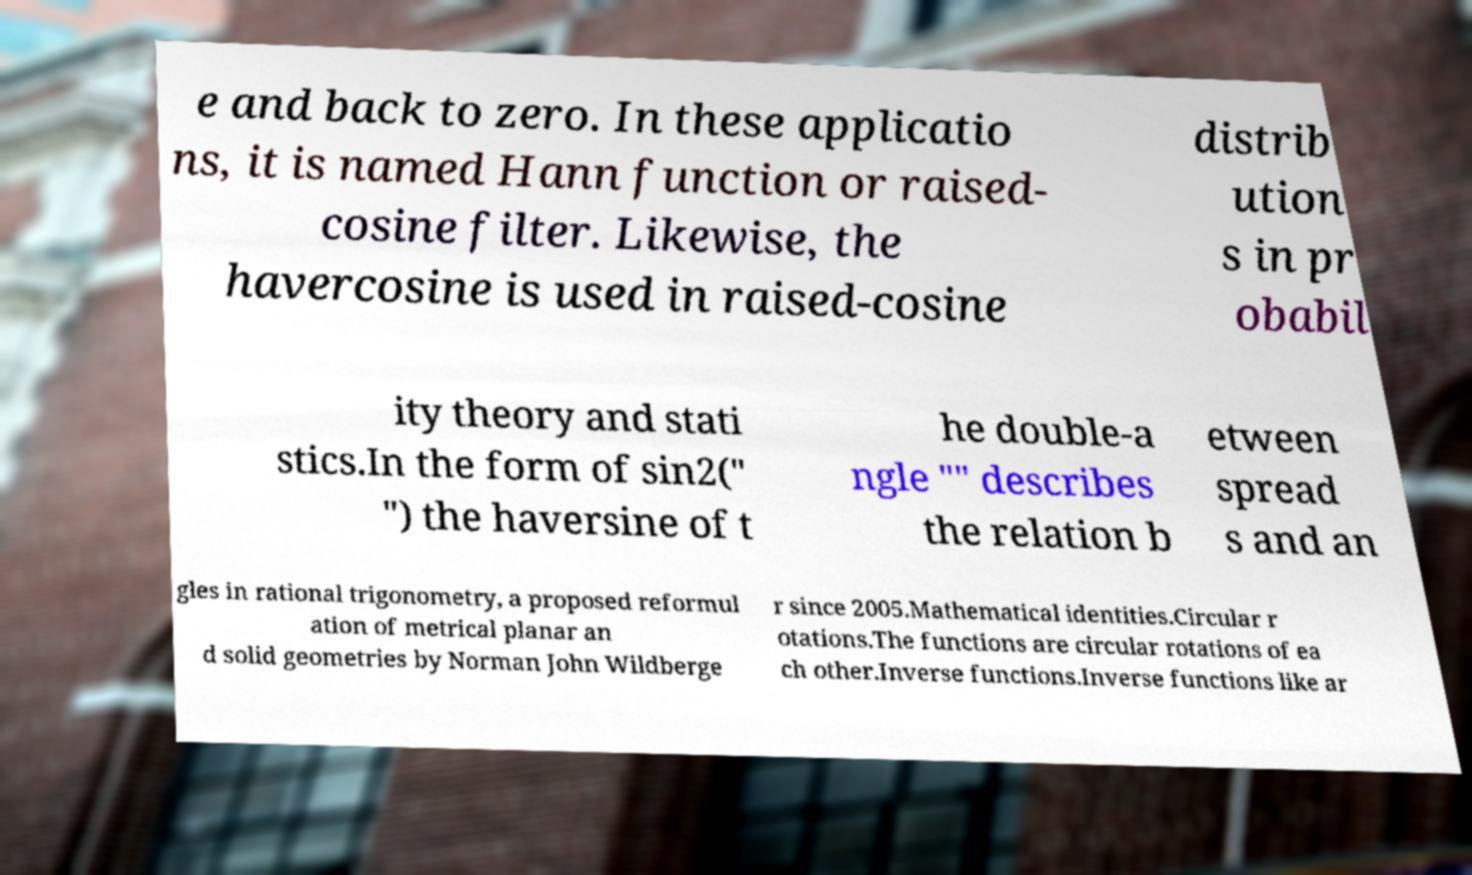Could you assist in decoding the text presented in this image and type it out clearly? e and back to zero. In these applicatio ns, it is named Hann function or raised- cosine filter. Likewise, the havercosine is used in raised-cosine distrib ution s in pr obabil ity theory and stati stics.In the form of sin2(" ") the haversine of t he double-a ngle "" describes the relation b etween spread s and an gles in rational trigonometry, a proposed reformul ation of metrical planar an d solid geometries by Norman John Wildberge r since 2005.Mathematical identities.Circular r otations.The functions are circular rotations of ea ch other.Inverse functions.Inverse functions like ar 